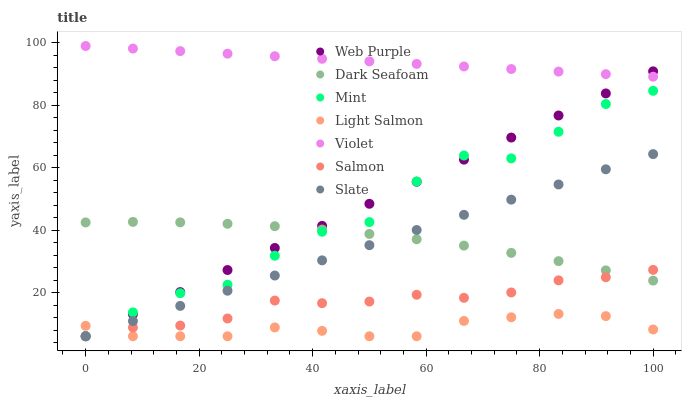Does Light Salmon have the minimum area under the curve?
Answer yes or no. Yes. Does Violet have the maximum area under the curve?
Answer yes or no. Yes. Does Slate have the minimum area under the curve?
Answer yes or no. No. Does Slate have the maximum area under the curve?
Answer yes or no. No. Is Web Purple the smoothest?
Answer yes or no. Yes. Is Mint the roughest?
Answer yes or no. Yes. Is Slate the smoothest?
Answer yes or no. No. Is Slate the roughest?
Answer yes or no. No. Does Light Salmon have the lowest value?
Answer yes or no. Yes. Does Dark Seafoam have the lowest value?
Answer yes or no. No. Does Violet have the highest value?
Answer yes or no. Yes. Does Slate have the highest value?
Answer yes or no. No. Is Slate less than Violet?
Answer yes or no. Yes. Is Violet greater than Light Salmon?
Answer yes or no. Yes. Does Light Salmon intersect Web Purple?
Answer yes or no. Yes. Is Light Salmon less than Web Purple?
Answer yes or no. No. Is Light Salmon greater than Web Purple?
Answer yes or no. No. Does Slate intersect Violet?
Answer yes or no. No. 